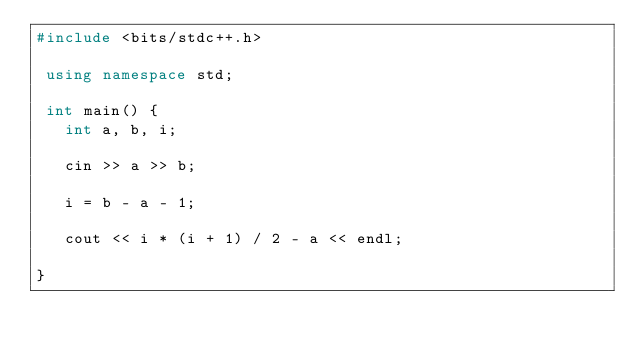<code> <loc_0><loc_0><loc_500><loc_500><_C++_>#include <bits/stdc++.h>

 using namespace std;

 int main() {
   int a, b, i;

   cin >> a >> b;

   i = b - a - 1;

   cout << i * (i + 1) / 2 - a << endl;

}
</code> 